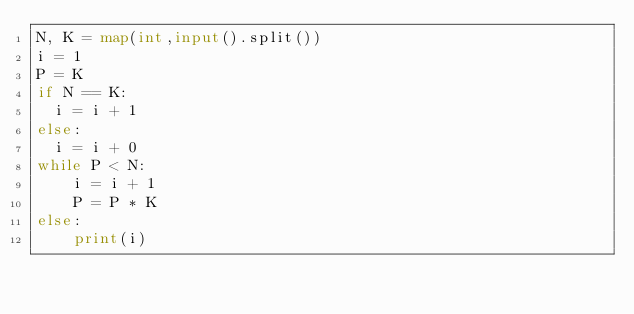Convert code to text. <code><loc_0><loc_0><loc_500><loc_500><_Python_>N, K = map(int,input().split())
i = 1
P = K
if N == K:
  i = i + 1
else:
  i = i + 0
while P < N:
	i = i + 1
	P = P * K
else:
	print(i)</code> 